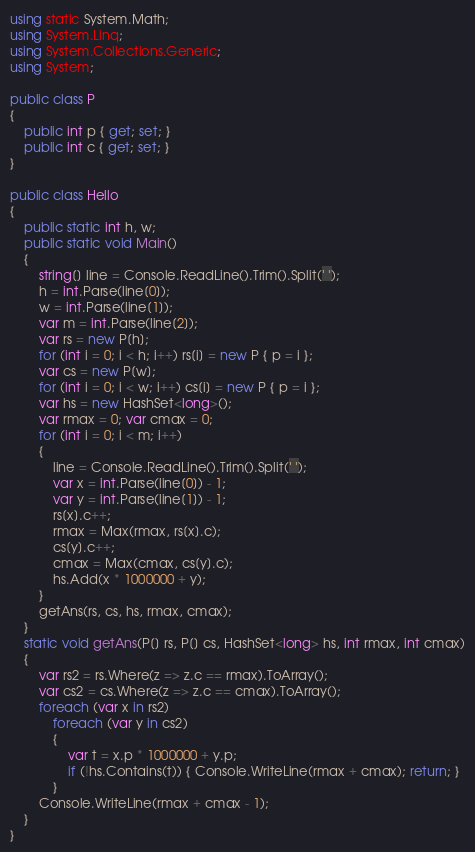<code> <loc_0><loc_0><loc_500><loc_500><_C#_>using static System.Math;
using System.Linq;
using System.Collections.Generic;
using System;

public class P
{
    public int p { get; set; }
    public int c { get; set; }
}

public class Hello
{
    public static int h, w;
    public static void Main()
    {
        string[] line = Console.ReadLine().Trim().Split(' ');
        h = int.Parse(line[0]);
        w = int.Parse(line[1]);
        var m = int.Parse(line[2]);
        var rs = new P[h];
        for (int i = 0; i < h; i++) rs[i] = new P { p = i };
        var cs = new P[w];
        for (int i = 0; i < w; i++) cs[i] = new P { p = i };
        var hs = new HashSet<long>();
        var rmax = 0; var cmax = 0;
        for (int i = 0; i < m; i++)
        {
            line = Console.ReadLine().Trim().Split(' ');
            var x = int.Parse(line[0]) - 1;
            var y = int.Parse(line[1]) - 1;
            rs[x].c++;
            rmax = Max(rmax, rs[x].c);
            cs[y].c++;
            cmax = Max(cmax, cs[y].c);
            hs.Add(x * 1000000 + y);
        }
        getAns(rs, cs, hs, rmax, cmax);
    }
    static void getAns(P[] rs, P[] cs, HashSet<long> hs, int rmax, int cmax)
    {
        var rs2 = rs.Where(z => z.c == rmax).ToArray();
        var cs2 = cs.Where(z => z.c == cmax).ToArray();
        foreach (var x in rs2)
            foreach (var y in cs2)
            {
                var t = x.p * 1000000 + y.p;
                if (!hs.Contains(t)) { Console.WriteLine(rmax + cmax); return; }
            }
        Console.WriteLine(rmax + cmax - 1);
    }
}
</code> 